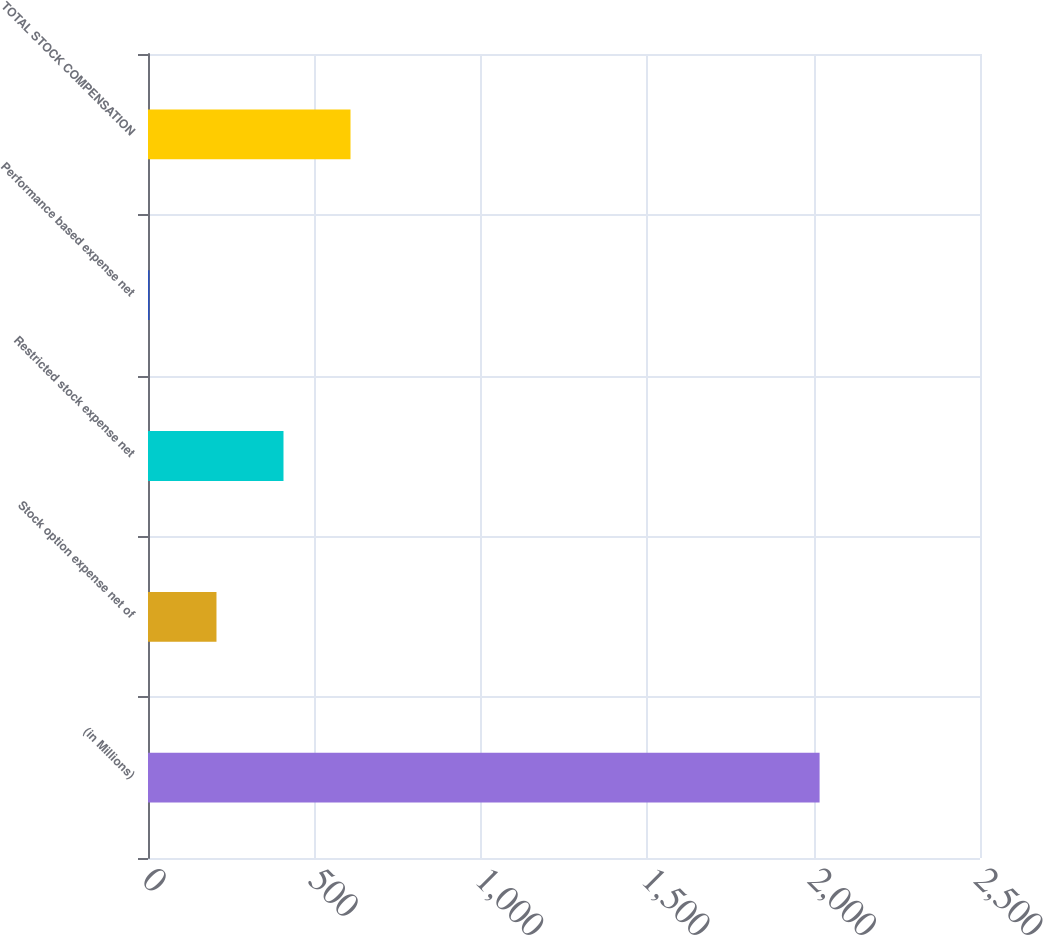<chart> <loc_0><loc_0><loc_500><loc_500><bar_chart><fcel>(in Millions)<fcel>Stock option expense net of<fcel>Restricted stock expense net<fcel>Performance based expense net<fcel>TOTAL STOCK COMPENSATION<nl><fcel>2018<fcel>205.76<fcel>407.12<fcel>4.4<fcel>608.48<nl></chart> 